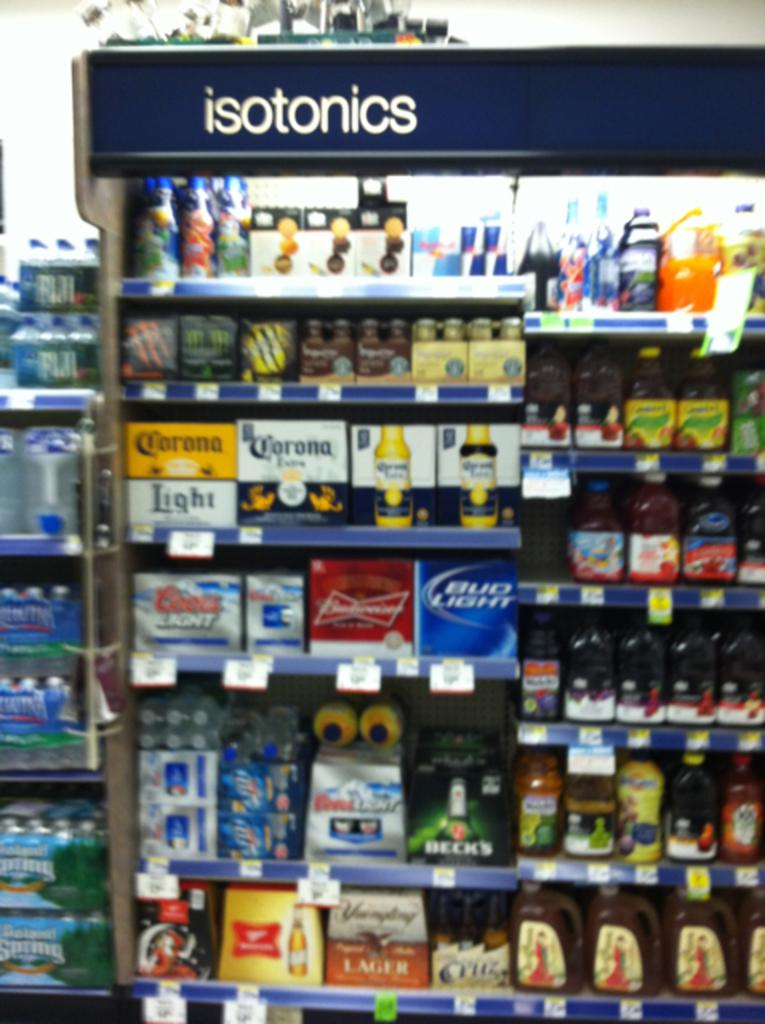What can be seen in the racks in the image? There are objects placed in the racks. Can you describe the text at the top of a stand in the image? Unfortunately, the provided facts do not give any information about the text at the top of a stand. What is the name of the daughter in the image? There is no daughter present in the image. What type of bed can be seen in the image? There is no bed present in the image. 